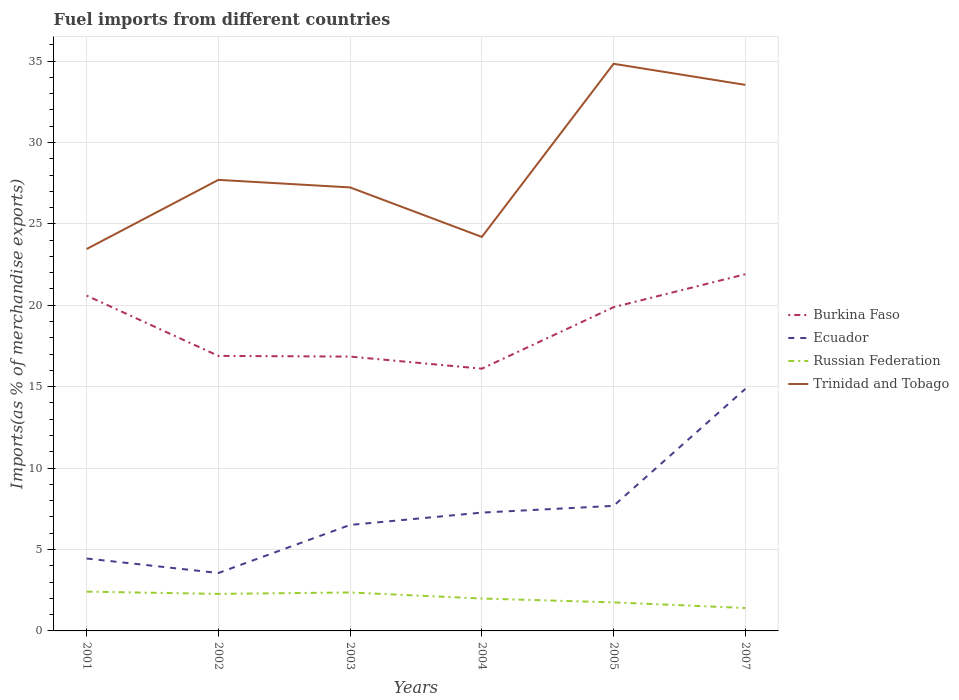How many different coloured lines are there?
Make the answer very short. 4. Does the line corresponding to Ecuador intersect with the line corresponding to Trinidad and Tobago?
Provide a succinct answer. No. Across all years, what is the maximum percentage of imports to different countries in Burkina Faso?
Your answer should be very brief. 16.11. In which year was the percentage of imports to different countries in Russian Federation maximum?
Offer a very short reply. 2007. What is the total percentage of imports to different countries in Ecuador in the graph?
Keep it short and to the point. -8.36. What is the difference between the highest and the second highest percentage of imports to different countries in Russian Federation?
Make the answer very short. 1. What is the difference between the highest and the lowest percentage of imports to different countries in Ecuador?
Offer a very short reply. 2. How many years are there in the graph?
Provide a succinct answer. 6. What is the difference between two consecutive major ticks on the Y-axis?
Provide a short and direct response. 5. Does the graph contain any zero values?
Ensure brevity in your answer.  No. Does the graph contain grids?
Ensure brevity in your answer.  Yes. How many legend labels are there?
Offer a very short reply. 4. What is the title of the graph?
Offer a terse response. Fuel imports from different countries. Does "Middle income" appear as one of the legend labels in the graph?
Keep it short and to the point. No. What is the label or title of the Y-axis?
Provide a succinct answer. Imports(as % of merchandise exports). What is the Imports(as % of merchandise exports) of Burkina Faso in 2001?
Make the answer very short. 20.59. What is the Imports(as % of merchandise exports) in Ecuador in 2001?
Keep it short and to the point. 4.45. What is the Imports(as % of merchandise exports) of Russian Federation in 2001?
Keep it short and to the point. 2.41. What is the Imports(as % of merchandise exports) in Trinidad and Tobago in 2001?
Offer a terse response. 23.46. What is the Imports(as % of merchandise exports) in Burkina Faso in 2002?
Provide a succinct answer. 16.89. What is the Imports(as % of merchandise exports) of Ecuador in 2002?
Give a very brief answer. 3.56. What is the Imports(as % of merchandise exports) in Russian Federation in 2002?
Give a very brief answer. 2.27. What is the Imports(as % of merchandise exports) in Trinidad and Tobago in 2002?
Provide a succinct answer. 27.7. What is the Imports(as % of merchandise exports) in Burkina Faso in 2003?
Keep it short and to the point. 16.85. What is the Imports(as % of merchandise exports) of Ecuador in 2003?
Your answer should be very brief. 6.51. What is the Imports(as % of merchandise exports) of Russian Federation in 2003?
Your answer should be very brief. 2.36. What is the Imports(as % of merchandise exports) of Trinidad and Tobago in 2003?
Your answer should be very brief. 27.24. What is the Imports(as % of merchandise exports) in Burkina Faso in 2004?
Make the answer very short. 16.11. What is the Imports(as % of merchandise exports) in Ecuador in 2004?
Provide a succinct answer. 7.27. What is the Imports(as % of merchandise exports) of Russian Federation in 2004?
Your response must be concise. 1.99. What is the Imports(as % of merchandise exports) of Trinidad and Tobago in 2004?
Your response must be concise. 24.2. What is the Imports(as % of merchandise exports) in Burkina Faso in 2005?
Give a very brief answer. 19.88. What is the Imports(as % of merchandise exports) of Ecuador in 2005?
Your response must be concise. 7.68. What is the Imports(as % of merchandise exports) in Russian Federation in 2005?
Offer a very short reply. 1.75. What is the Imports(as % of merchandise exports) of Trinidad and Tobago in 2005?
Your response must be concise. 34.83. What is the Imports(as % of merchandise exports) of Burkina Faso in 2007?
Offer a terse response. 21.91. What is the Imports(as % of merchandise exports) of Ecuador in 2007?
Offer a very short reply. 14.87. What is the Imports(as % of merchandise exports) of Russian Federation in 2007?
Ensure brevity in your answer.  1.41. What is the Imports(as % of merchandise exports) of Trinidad and Tobago in 2007?
Keep it short and to the point. 33.54. Across all years, what is the maximum Imports(as % of merchandise exports) of Burkina Faso?
Ensure brevity in your answer.  21.91. Across all years, what is the maximum Imports(as % of merchandise exports) of Ecuador?
Keep it short and to the point. 14.87. Across all years, what is the maximum Imports(as % of merchandise exports) of Russian Federation?
Provide a succinct answer. 2.41. Across all years, what is the maximum Imports(as % of merchandise exports) in Trinidad and Tobago?
Offer a terse response. 34.83. Across all years, what is the minimum Imports(as % of merchandise exports) in Burkina Faso?
Make the answer very short. 16.11. Across all years, what is the minimum Imports(as % of merchandise exports) of Ecuador?
Your answer should be compact. 3.56. Across all years, what is the minimum Imports(as % of merchandise exports) in Russian Federation?
Provide a short and direct response. 1.41. Across all years, what is the minimum Imports(as % of merchandise exports) in Trinidad and Tobago?
Provide a short and direct response. 23.46. What is the total Imports(as % of merchandise exports) of Burkina Faso in the graph?
Provide a short and direct response. 112.23. What is the total Imports(as % of merchandise exports) of Ecuador in the graph?
Ensure brevity in your answer.  44.33. What is the total Imports(as % of merchandise exports) in Russian Federation in the graph?
Keep it short and to the point. 12.2. What is the total Imports(as % of merchandise exports) of Trinidad and Tobago in the graph?
Provide a succinct answer. 170.96. What is the difference between the Imports(as % of merchandise exports) in Burkina Faso in 2001 and that in 2002?
Provide a short and direct response. 3.7. What is the difference between the Imports(as % of merchandise exports) of Ecuador in 2001 and that in 2002?
Offer a very short reply. 0.89. What is the difference between the Imports(as % of merchandise exports) of Russian Federation in 2001 and that in 2002?
Your answer should be very brief. 0.14. What is the difference between the Imports(as % of merchandise exports) of Trinidad and Tobago in 2001 and that in 2002?
Give a very brief answer. -4.25. What is the difference between the Imports(as % of merchandise exports) of Burkina Faso in 2001 and that in 2003?
Keep it short and to the point. 3.74. What is the difference between the Imports(as % of merchandise exports) in Ecuador in 2001 and that in 2003?
Your response must be concise. -2.06. What is the difference between the Imports(as % of merchandise exports) of Russian Federation in 2001 and that in 2003?
Your response must be concise. 0.05. What is the difference between the Imports(as % of merchandise exports) of Trinidad and Tobago in 2001 and that in 2003?
Your response must be concise. -3.78. What is the difference between the Imports(as % of merchandise exports) of Burkina Faso in 2001 and that in 2004?
Keep it short and to the point. 4.49. What is the difference between the Imports(as % of merchandise exports) in Ecuador in 2001 and that in 2004?
Offer a very short reply. -2.82. What is the difference between the Imports(as % of merchandise exports) of Russian Federation in 2001 and that in 2004?
Offer a terse response. 0.42. What is the difference between the Imports(as % of merchandise exports) in Trinidad and Tobago in 2001 and that in 2004?
Make the answer very short. -0.74. What is the difference between the Imports(as % of merchandise exports) in Burkina Faso in 2001 and that in 2005?
Provide a succinct answer. 0.71. What is the difference between the Imports(as % of merchandise exports) of Ecuador in 2001 and that in 2005?
Provide a succinct answer. -3.23. What is the difference between the Imports(as % of merchandise exports) of Russian Federation in 2001 and that in 2005?
Ensure brevity in your answer.  0.66. What is the difference between the Imports(as % of merchandise exports) in Trinidad and Tobago in 2001 and that in 2005?
Your answer should be compact. -11.38. What is the difference between the Imports(as % of merchandise exports) in Burkina Faso in 2001 and that in 2007?
Keep it short and to the point. -1.31. What is the difference between the Imports(as % of merchandise exports) in Ecuador in 2001 and that in 2007?
Ensure brevity in your answer.  -10.42. What is the difference between the Imports(as % of merchandise exports) in Trinidad and Tobago in 2001 and that in 2007?
Offer a very short reply. -10.08. What is the difference between the Imports(as % of merchandise exports) of Burkina Faso in 2002 and that in 2003?
Keep it short and to the point. 0.04. What is the difference between the Imports(as % of merchandise exports) in Ecuador in 2002 and that in 2003?
Keep it short and to the point. -2.95. What is the difference between the Imports(as % of merchandise exports) in Russian Federation in 2002 and that in 2003?
Provide a short and direct response. -0.09. What is the difference between the Imports(as % of merchandise exports) of Trinidad and Tobago in 2002 and that in 2003?
Your response must be concise. 0.46. What is the difference between the Imports(as % of merchandise exports) of Burkina Faso in 2002 and that in 2004?
Give a very brief answer. 0.78. What is the difference between the Imports(as % of merchandise exports) in Ecuador in 2002 and that in 2004?
Keep it short and to the point. -3.71. What is the difference between the Imports(as % of merchandise exports) in Russian Federation in 2002 and that in 2004?
Ensure brevity in your answer.  0.28. What is the difference between the Imports(as % of merchandise exports) in Trinidad and Tobago in 2002 and that in 2004?
Offer a terse response. 3.5. What is the difference between the Imports(as % of merchandise exports) of Burkina Faso in 2002 and that in 2005?
Offer a very short reply. -2.99. What is the difference between the Imports(as % of merchandise exports) in Ecuador in 2002 and that in 2005?
Ensure brevity in your answer.  -4.12. What is the difference between the Imports(as % of merchandise exports) of Russian Federation in 2002 and that in 2005?
Give a very brief answer. 0.52. What is the difference between the Imports(as % of merchandise exports) of Trinidad and Tobago in 2002 and that in 2005?
Your answer should be very brief. -7.13. What is the difference between the Imports(as % of merchandise exports) of Burkina Faso in 2002 and that in 2007?
Offer a very short reply. -5.02. What is the difference between the Imports(as % of merchandise exports) of Ecuador in 2002 and that in 2007?
Give a very brief answer. -11.31. What is the difference between the Imports(as % of merchandise exports) in Russian Federation in 2002 and that in 2007?
Offer a very short reply. 0.87. What is the difference between the Imports(as % of merchandise exports) in Trinidad and Tobago in 2002 and that in 2007?
Provide a succinct answer. -5.83. What is the difference between the Imports(as % of merchandise exports) of Burkina Faso in 2003 and that in 2004?
Provide a succinct answer. 0.74. What is the difference between the Imports(as % of merchandise exports) in Ecuador in 2003 and that in 2004?
Make the answer very short. -0.76. What is the difference between the Imports(as % of merchandise exports) in Russian Federation in 2003 and that in 2004?
Ensure brevity in your answer.  0.37. What is the difference between the Imports(as % of merchandise exports) in Trinidad and Tobago in 2003 and that in 2004?
Make the answer very short. 3.04. What is the difference between the Imports(as % of merchandise exports) in Burkina Faso in 2003 and that in 2005?
Your response must be concise. -3.04. What is the difference between the Imports(as % of merchandise exports) in Ecuador in 2003 and that in 2005?
Offer a terse response. -1.17. What is the difference between the Imports(as % of merchandise exports) of Russian Federation in 2003 and that in 2005?
Offer a terse response. 0.61. What is the difference between the Imports(as % of merchandise exports) in Trinidad and Tobago in 2003 and that in 2005?
Give a very brief answer. -7.59. What is the difference between the Imports(as % of merchandise exports) of Burkina Faso in 2003 and that in 2007?
Give a very brief answer. -5.06. What is the difference between the Imports(as % of merchandise exports) in Ecuador in 2003 and that in 2007?
Make the answer very short. -8.36. What is the difference between the Imports(as % of merchandise exports) in Russian Federation in 2003 and that in 2007?
Your answer should be very brief. 0.95. What is the difference between the Imports(as % of merchandise exports) in Trinidad and Tobago in 2003 and that in 2007?
Offer a very short reply. -6.3. What is the difference between the Imports(as % of merchandise exports) in Burkina Faso in 2004 and that in 2005?
Your answer should be very brief. -3.78. What is the difference between the Imports(as % of merchandise exports) of Ecuador in 2004 and that in 2005?
Provide a succinct answer. -0.41. What is the difference between the Imports(as % of merchandise exports) of Russian Federation in 2004 and that in 2005?
Make the answer very short. 0.24. What is the difference between the Imports(as % of merchandise exports) in Trinidad and Tobago in 2004 and that in 2005?
Ensure brevity in your answer.  -10.63. What is the difference between the Imports(as % of merchandise exports) of Burkina Faso in 2004 and that in 2007?
Offer a very short reply. -5.8. What is the difference between the Imports(as % of merchandise exports) of Ecuador in 2004 and that in 2007?
Offer a terse response. -7.6. What is the difference between the Imports(as % of merchandise exports) of Russian Federation in 2004 and that in 2007?
Ensure brevity in your answer.  0.58. What is the difference between the Imports(as % of merchandise exports) of Trinidad and Tobago in 2004 and that in 2007?
Your answer should be compact. -9.34. What is the difference between the Imports(as % of merchandise exports) in Burkina Faso in 2005 and that in 2007?
Your answer should be compact. -2.02. What is the difference between the Imports(as % of merchandise exports) of Ecuador in 2005 and that in 2007?
Provide a short and direct response. -7.19. What is the difference between the Imports(as % of merchandise exports) of Russian Federation in 2005 and that in 2007?
Offer a terse response. 0.35. What is the difference between the Imports(as % of merchandise exports) in Trinidad and Tobago in 2005 and that in 2007?
Keep it short and to the point. 1.3. What is the difference between the Imports(as % of merchandise exports) in Burkina Faso in 2001 and the Imports(as % of merchandise exports) in Ecuador in 2002?
Your response must be concise. 17.04. What is the difference between the Imports(as % of merchandise exports) in Burkina Faso in 2001 and the Imports(as % of merchandise exports) in Russian Federation in 2002?
Make the answer very short. 18.32. What is the difference between the Imports(as % of merchandise exports) in Burkina Faso in 2001 and the Imports(as % of merchandise exports) in Trinidad and Tobago in 2002?
Your answer should be compact. -7.11. What is the difference between the Imports(as % of merchandise exports) of Ecuador in 2001 and the Imports(as % of merchandise exports) of Russian Federation in 2002?
Your answer should be compact. 2.17. What is the difference between the Imports(as % of merchandise exports) of Ecuador in 2001 and the Imports(as % of merchandise exports) of Trinidad and Tobago in 2002?
Ensure brevity in your answer.  -23.26. What is the difference between the Imports(as % of merchandise exports) of Russian Federation in 2001 and the Imports(as % of merchandise exports) of Trinidad and Tobago in 2002?
Make the answer very short. -25.29. What is the difference between the Imports(as % of merchandise exports) in Burkina Faso in 2001 and the Imports(as % of merchandise exports) in Ecuador in 2003?
Give a very brief answer. 14.08. What is the difference between the Imports(as % of merchandise exports) of Burkina Faso in 2001 and the Imports(as % of merchandise exports) of Russian Federation in 2003?
Offer a very short reply. 18.23. What is the difference between the Imports(as % of merchandise exports) of Burkina Faso in 2001 and the Imports(as % of merchandise exports) of Trinidad and Tobago in 2003?
Keep it short and to the point. -6.64. What is the difference between the Imports(as % of merchandise exports) in Ecuador in 2001 and the Imports(as % of merchandise exports) in Russian Federation in 2003?
Keep it short and to the point. 2.08. What is the difference between the Imports(as % of merchandise exports) in Ecuador in 2001 and the Imports(as % of merchandise exports) in Trinidad and Tobago in 2003?
Provide a succinct answer. -22.79. What is the difference between the Imports(as % of merchandise exports) of Russian Federation in 2001 and the Imports(as % of merchandise exports) of Trinidad and Tobago in 2003?
Make the answer very short. -24.83. What is the difference between the Imports(as % of merchandise exports) in Burkina Faso in 2001 and the Imports(as % of merchandise exports) in Ecuador in 2004?
Your response must be concise. 13.33. What is the difference between the Imports(as % of merchandise exports) in Burkina Faso in 2001 and the Imports(as % of merchandise exports) in Russian Federation in 2004?
Keep it short and to the point. 18.6. What is the difference between the Imports(as % of merchandise exports) of Burkina Faso in 2001 and the Imports(as % of merchandise exports) of Trinidad and Tobago in 2004?
Provide a short and direct response. -3.6. What is the difference between the Imports(as % of merchandise exports) of Ecuador in 2001 and the Imports(as % of merchandise exports) of Russian Federation in 2004?
Your response must be concise. 2.46. What is the difference between the Imports(as % of merchandise exports) of Ecuador in 2001 and the Imports(as % of merchandise exports) of Trinidad and Tobago in 2004?
Offer a very short reply. -19.75. What is the difference between the Imports(as % of merchandise exports) of Russian Federation in 2001 and the Imports(as % of merchandise exports) of Trinidad and Tobago in 2004?
Your answer should be compact. -21.79. What is the difference between the Imports(as % of merchandise exports) of Burkina Faso in 2001 and the Imports(as % of merchandise exports) of Ecuador in 2005?
Give a very brief answer. 12.91. What is the difference between the Imports(as % of merchandise exports) in Burkina Faso in 2001 and the Imports(as % of merchandise exports) in Russian Federation in 2005?
Offer a terse response. 18.84. What is the difference between the Imports(as % of merchandise exports) of Burkina Faso in 2001 and the Imports(as % of merchandise exports) of Trinidad and Tobago in 2005?
Offer a very short reply. -14.24. What is the difference between the Imports(as % of merchandise exports) in Ecuador in 2001 and the Imports(as % of merchandise exports) in Russian Federation in 2005?
Offer a very short reply. 2.69. What is the difference between the Imports(as % of merchandise exports) in Ecuador in 2001 and the Imports(as % of merchandise exports) in Trinidad and Tobago in 2005?
Make the answer very short. -30.38. What is the difference between the Imports(as % of merchandise exports) of Russian Federation in 2001 and the Imports(as % of merchandise exports) of Trinidad and Tobago in 2005?
Your answer should be compact. -32.42. What is the difference between the Imports(as % of merchandise exports) in Burkina Faso in 2001 and the Imports(as % of merchandise exports) in Ecuador in 2007?
Your answer should be compact. 5.73. What is the difference between the Imports(as % of merchandise exports) of Burkina Faso in 2001 and the Imports(as % of merchandise exports) of Russian Federation in 2007?
Offer a terse response. 19.19. What is the difference between the Imports(as % of merchandise exports) of Burkina Faso in 2001 and the Imports(as % of merchandise exports) of Trinidad and Tobago in 2007?
Provide a succinct answer. -12.94. What is the difference between the Imports(as % of merchandise exports) of Ecuador in 2001 and the Imports(as % of merchandise exports) of Russian Federation in 2007?
Offer a terse response. 3.04. What is the difference between the Imports(as % of merchandise exports) of Ecuador in 2001 and the Imports(as % of merchandise exports) of Trinidad and Tobago in 2007?
Your response must be concise. -29.09. What is the difference between the Imports(as % of merchandise exports) in Russian Federation in 2001 and the Imports(as % of merchandise exports) in Trinidad and Tobago in 2007?
Keep it short and to the point. -31.12. What is the difference between the Imports(as % of merchandise exports) in Burkina Faso in 2002 and the Imports(as % of merchandise exports) in Ecuador in 2003?
Keep it short and to the point. 10.38. What is the difference between the Imports(as % of merchandise exports) of Burkina Faso in 2002 and the Imports(as % of merchandise exports) of Russian Federation in 2003?
Provide a succinct answer. 14.53. What is the difference between the Imports(as % of merchandise exports) in Burkina Faso in 2002 and the Imports(as % of merchandise exports) in Trinidad and Tobago in 2003?
Ensure brevity in your answer.  -10.35. What is the difference between the Imports(as % of merchandise exports) of Ecuador in 2002 and the Imports(as % of merchandise exports) of Russian Federation in 2003?
Offer a very short reply. 1.2. What is the difference between the Imports(as % of merchandise exports) in Ecuador in 2002 and the Imports(as % of merchandise exports) in Trinidad and Tobago in 2003?
Ensure brevity in your answer.  -23.68. What is the difference between the Imports(as % of merchandise exports) of Russian Federation in 2002 and the Imports(as % of merchandise exports) of Trinidad and Tobago in 2003?
Offer a terse response. -24.96. What is the difference between the Imports(as % of merchandise exports) of Burkina Faso in 2002 and the Imports(as % of merchandise exports) of Ecuador in 2004?
Your answer should be compact. 9.62. What is the difference between the Imports(as % of merchandise exports) in Burkina Faso in 2002 and the Imports(as % of merchandise exports) in Russian Federation in 2004?
Ensure brevity in your answer.  14.9. What is the difference between the Imports(as % of merchandise exports) in Burkina Faso in 2002 and the Imports(as % of merchandise exports) in Trinidad and Tobago in 2004?
Make the answer very short. -7.31. What is the difference between the Imports(as % of merchandise exports) in Ecuador in 2002 and the Imports(as % of merchandise exports) in Russian Federation in 2004?
Make the answer very short. 1.57. What is the difference between the Imports(as % of merchandise exports) in Ecuador in 2002 and the Imports(as % of merchandise exports) in Trinidad and Tobago in 2004?
Your response must be concise. -20.64. What is the difference between the Imports(as % of merchandise exports) in Russian Federation in 2002 and the Imports(as % of merchandise exports) in Trinidad and Tobago in 2004?
Ensure brevity in your answer.  -21.92. What is the difference between the Imports(as % of merchandise exports) of Burkina Faso in 2002 and the Imports(as % of merchandise exports) of Ecuador in 2005?
Give a very brief answer. 9.21. What is the difference between the Imports(as % of merchandise exports) in Burkina Faso in 2002 and the Imports(as % of merchandise exports) in Russian Federation in 2005?
Ensure brevity in your answer.  15.14. What is the difference between the Imports(as % of merchandise exports) in Burkina Faso in 2002 and the Imports(as % of merchandise exports) in Trinidad and Tobago in 2005?
Make the answer very short. -17.94. What is the difference between the Imports(as % of merchandise exports) in Ecuador in 2002 and the Imports(as % of merchandise exports) in Russian Federation in 2005?
Keep it short and to the point. 1.8. What is the difference between the Imports(as % of merchandise exports) of Ecuador in 2002 and the Imports(as % of merchandise exports) of Trinidad and Tobago in 2005?
Give a very brief answer. -31.27. What is the difference between the Imports(as % of merchandise exports) in Russian Federation in 2002 and the Imports(as % of merchandise exports) in Trinidad and Tobago in 2005?
Make the answer very short. -32.56. What is the difference between the Imports(as % of merchandise exports) of Burkina Faso in 2002 and the Imports(as % of merchandise exports) of Ecuador in 2007?
Offer a terse response. 2.02. What is the difference between the Imports(as % of merchandise exports) of Burkina Faso in 2002 and the Imports(as % of merchandise exports) of Russian Federation in 2007?
Provide a short and direct response. 15.48. What is the difference between the Imports(as % of merchandise exports) of Burkina Faso in 2002 and the Imports(as % of merchandise exports) of Trinidad and Tobago in 2007?
Offer a terse response. -16.65. What is the difference between the Imports(as % of merchandise exports) in Ecuador in 2002 and the Imports(as % of merchandise exports) in Russian Federation in 2007?
Give a very brief answer. 2.15. What is the difference between the Imports(as % of merchandise exports) of Ecuador in 2002 and the Imports(as % of merchandise exports) of Trinidad and Tobago in 2007?
Offer a terse response. -29.98. What is the difference between the Imports(as % of merchandise exports) of Russian Federation in 2002 and the Imports(as % of merchandise exports) of Trinidad and Tobago in 2007?
Keep it short and to the point. -31.26. What is the difference between the Imports(as % of merchandise exports) of Burkina Faso in 2003 and the Imports(as % of merchandise exports) of Ecuador in 2004?
Your answer should be compact. 9.58. What is the difference between the Imports(as % of merchandise exports) of Burkina Faso in 2003 and the Imports(as % of merchandise exports) of Russian Federation in 2004?
Your answer should be compact. 14.86. What is the difference between the Imports(as % of merchandise exports) of Burkina Faso in 2003 and the Imports(as % of merchandise exports) of Trinidad and Tobago in 2004?
Ensure brevity in your answer.  -7.35. What is the difference between the Imports(as % of merchandise exports) of Ecuador in 2003 and the Imports(as % of merchandise exports) of Russian Federation in 2004?
Offer a terse response. 4.52. What is the difference between the Imports(as % of merchandise exports) in Ecuador in 2003 and the Imports(as % of merchandise exports) in Trinidad and Tobago in 2004?
Provide a succinct answer. -17.69. What is the difference between the Imports(as % of merchandise exports) in Russian Federation in 2003 and the Imports(as % of merchandise exports) in Trinidad and Tobago in 2004?
Provide a short and direct response. -21.84. What is the difference between the Imports(as % of merchandise exports) in Burkina Faso in 2003 and the Imports(as % of merchandise exports) in Ecuador in 2005?
Provide a succinct answer. 9.17. What is the difference between the Imports(as % of merchandise exports) of Burkina Faso in 2003 and the Imports(as % of merchandise exports) of Russian Federation in 2005?
Keep it short and to the point. 15.1. What is the difference between the Imports(as % of merchandise exports) of Burkina Faso in 2003 and the Imports(as % of merchandise exports) of Trinidad and Tobago in 2005?
Provide a succinct answer. -17.98. What is the difference between the Imports(as % of merchandise exports) in Ecuador in 2003 and the Imports(as % of merchandise exports) in Russian Federation in 2005?
Provide a succinct answer. 4.76. What is the difference between the Imports(as % of merchandise exports) of Ecuador in 2003 and the Imports(as % of merchandise exports) of Trinidad and Tobago in 2005?
Offer a terse response. -28.32. What is the difference between the Imports(as % of merchandise exports) in Russian Federation in 2003 and the Imports(as % of merchandise exports) in Trinidad and Tobago in 2005?
Keep it short and to the point. -32.47. What is the difference between the Imports(as % of merchandise exports) in Burkina Faso in 2003 and the Imports(as % of merchandise exports) in Ecuador in 2007?
Provide a succinct answer. 1.98. What is the difference between the Imports(as % of merchandise exports) in Burkina Faso in 2003 and the Imports(as % of merchandise exports) in Russian Federation in 2007?
Keep it short and to the point. 15.44. What is the difference between the Imports(as % of merchandise exports) of Burkina Faso in 2003 and the Imports(as % of merchandise exports) of Trinidad and Tobago in 2007?
Keep it short and to the point. -16.69. What is the difference between the Imports(as % of merchandise exports) in Ecuador in 2003 and the Imports(as % of merchandise exports) in Russian Federation in 2007?
Your response must be concise. 5.1. What is the difference between the Imports(as % of merchandise exports) in Ecuador in 2003 and the Imports(as % of merchandise exports) in Trinidad and Tobago in 2007?
Give a very brief answer. -27.03. What is the difference between the Imports(as % of merchandise exports) of Russian Federation in 2003 and the Imports(as % of merchandise exports) of Trinidad and Tobago in 2007?
Ensure brevity in your answer.  -31.17. What is the difference between the Imports(as % of merchandise exports) of Burkina Faso in 2004 and the Imports(as % of merchandise exports) of Ecuador in 2005?
Keep it short and to the point. 8.42. What is the difference between the Imports(as % of merchandise exports) of Burkina Faso in 2004 and the Imports(as % of merchandise exports) of Russian Federation in 2005?
Ensure brevity in your answer.  14.35. What is the difference between the Imports(as % of merchandise exports) of Burkina Faso in 2004 and the Imports(as % of merchandise exports) of Trinidad and Tobago in 2005?
Keep it short and to the point. -18.73. What is the difference between the Imports(as % of merchandise exports) of Ecuador in 2004 and the Imports(as % of merchandise exports) of Russian Federation in 2005?
Offer a very short reply. 5.51. What is the difference between the Imports(as % of merchandise exports) in Ecuador in 2004 and the Imports(as % of merchandise exports) in Trinidad and Tobago in 2005?
Keep it short and to the point. -27.56. What is the difference between the Imports(as % of merchandise exports) in Russian Federation in 2004 and the Imports(as % of merchandise exports) in Trinidad and Tobago in 2005?
Provide a succinct answer. -32.84. What is the difference between the Imports(as % of merchandise exports) in Burkina Faso in 2004 and the Imports(as % of merchandise exports) in Ecuador in 2007?
Make the answer very short. 1.24. What is the difference between the Imports(as % of merchandise exports) in Burkina Faso in 2004 and the Imports(as % of merchandise exports) in Russian Federation in 2007?
Make the answer very short. 14.7. What is the difference between the Imports(as % of merchandise exports) in Burkina Faso in 2004 and the Imports(as % of merchandise exports) in Trinidad and Tobago in 2007?
Make the answer very short. -17.43. What is the difference between the Imports(as % of merchandise exports) in Ecuador in 2004 and the Imports(as % of merchandise exports) in Russian Federation in 2007?
Give a very brief answer. 5.86. What is the difference between the Imports(as % of merchandise exports) in Ecuador in 2004 and the Imports(as % of merchandise exports) in Trinidad and Tobago in 2007?
Ensure brevity in your answer.  -26.27. What is the difference between the Imports(as % of merchandise exports) of Russian Federation in 2004 and the Imports(as % of merchandise exports) of Trinidad and Tobago in 2007?
Provide a short and direct response. -31.55. What is the difference between the Imports(as % of merchandise exports) in Burkina Faso in 2005 and the Imports(as % of merchandise exports) in Ecuador in 2007?
Give a very brief answer. 5.02. What is the difference between the Imports(as % of merchandise exports) of Burkina Faso in 2005 and the Imports(as % of merchandise exports) of Russian Federation in 2007?
Provide a succinct answer. 18.48. What is the difference between the Imports(as % of merchandise exports) of Burkina Faso in 2005 and the Imports(as % of merchandise exports) of Trinidad and Tobago in 2007?
Provide a succinct answer. -13.65. What is the difference between the Imports(as % of merchandise exports) of Ecuador in 2005 and the Imports(as % of merchandise exports) of Russian Federation in 2007?
Make the answer very short. 6.27. What is the difference between the Imports(as % of merchandise exports) in Ecuador in 2005 and the Imports(as % of merchandise exports) in Trinidad and Tobago in 2007?
Offer a terse response. -25.85. What is the difference between the Imports(as % of merchandise exports) of Russian Federation in 2005 and the Imports(as % of merchandise exports) of Trinidad and Tobago in 2007?
Your answer should be very brief. -31.78. What is the average Imports(as % of merchandise exports) in Burkina Faso per year?
Your answer should be compact. 18.71. What is the average Imports(as % of merchandise exports) of Ecuador per year?
Give a very brief answer. 7.39. What is the average Imports(as % of merchandise exports) in Russian Federation per year?
Your answer should be compact. 2.03. What is the average Imports(as % of merchandise exports) in Trinidad and Tobago per year?
Your response must be concise. 28.49. In the year 2001, what is the difference between the Imports(as % of merchandise exports) of Burkina Faso and Imports(as % of merchandise exports) of Ecuador?
Give a very brief answer. 16.15. In the year 2001, what is the difference between the Imports(as % of merchandise exports) of Burkina Faso and Imports(as % of merchandise exports) of Russian Federation?
Provide a succinct answer. 18.18. In the year 2001, what is the difference between the Imports(as % of merchandise exports) in Burkina Faso and Imports(as % of merchandise exports) in Trinidad and Tobago?
Your response must be concise. -2.86. In the year 2001, what is the difference between the Imports(as % of merchandise exports) in Ecuador and Imports(as % of merchandise exports) in Russian Federation?
Provide a succinct answer. 2.03. In the year 2001, what is the difference between the Imports(as % of merchandise exports) of Ecuador and Imports(as % of merchandise exports) of Trinidad and Tobago?
Make the answer very short. -19.01. In the year 2001, what is the difference between the Imports(as % of merchandise exports) of Russian Federation and Imports(as % of merchandise exports) of Trinidad and Tobago?
Provide a short and direct response. -21.04. In the year 2002, what is the difference between the Imports(as % of merchandise exports) of Burkina Faso and Imports(as % of merchandise exports) of Ecuador?
Your answer should be very brief. 13.33. In the year 2002, what is the difference between the Imports(as % of merchandise exports) in Burkina Faso and Imports(as % of merchandise exports) in Russian Federation?
Your answer should be compact. 14.62. In the year 2002, what is the difference between the Imports(as % of merchandise exports) in Burkina Faso and Imports(as % of merchandise exports) in Trinidad and Tobago?
Make the answer very short. -10.81. In the year 2002, what is the difference between the Imports(as % of merchandise exports) in Ecuador and Imports(as % of merchandise exports) in Russian Federation?
Offer a very short reply. 1.28. In the year 2002, what is the difference between the Imports(as % of merchandise exports) in Ecuador and Imports(as % of merchandise exports) in Trinidad and Tobago?
Make the answer very short. -24.14. In the year 2002, what is the difference between the Imports(as % of merchandise exports) in Russian Federation and Imports(as % of merchandise exports) in Trinidad and Tobago?
Your answer should be very brief. -25.43. In the year 2003, what is the difference between the Imports(as % of merchandise exports) of Burkina Faso and Imports(as % of merchandise exports) of Ecuador?
Give a very brief answer. 10.34. In the year 2003, what is the difference between the Imports(as % of merchandise exports) of Burkina Faso and Imports(as % of merchandise exports) of Russian Federation?
Offer a terse response. 14.49. In the year 2003, what is the difference between the Imports(as % of merchandise exports) of Burkina Faso and Imports(as % of merchandise exports) of Trinidad and Tobago?
Give a very brief answer. -10.39. In the year 2003, what is the difference between the Imports(as % of merchandise exports) in Ecuador and Imports(as % of merchandise exports) in Russian Federation?
Keep it short and to the point. 4.15. In the year 2003, what is the difference between the Imports(as % of merchandise exports) in Ecuador and Imports(as % of merchandise exports) in Trinidad and Tobago?
Offer a very short reply. -20.73. In the year 2003, what is the difference between the Imports(as % of merchandise exports) of Russian Federation and Imports(as % of merchandise exports) of Trinidad and Tobago?
Keep it short and to the point. -24.88. In the year 2004, what is the difference between the Imports(as % of merchandise exports) of Burkina Faso and Imports(as % of merchandise exports) of Ecuador?
Give a very brief answer. 8.84. In the year 2004, what is the difference between the Imports(as % of merchandise exports) in Burkina Faso and Imports(as % of merchandise exports) in Russian Federation?
Your answer should be compact. 14.12. In the year 2004, what is the difference between the Imports(as % of merchandise exports) in Burkina Faso and Imports(as % of merchandise exports) in Trinidad and Tobago?
Keep it short and to the point. -8.09. In the year 2004, what is the difference between the Imports(as % of merchandise exports) of Ecuador and Imports(as % of merchandise exports) of Russian Federation?
Your answer should be very brief. 5.28. In the year 2004, what is the difference between the Imports(as % of merchandise exports) in Ecuador and Imports(as % of merchandise exports) in Trinidad and Tobago?
Ensure brevity in your answer.  -16.93. In the year 2004, what is the difference between the Imports(as % of merchandise exports) of Russian Federation and Imports(as % of merchandise exports) of Trinidad and Tobago?
Offer a very short reply. -22.21. In the year 2005, what is the difference between the Imports(as % of merchandise exports) in Burkina Faso and Imports(as % of merchandise exports) in Ecuador?
Provide a short and direct response. 12.2. In the year 2005, what is the difference between the Imports(as % of merchandise exports) in Burkina Faso and Imports(as % of merchandise exports) in Russian Federation?
Your answer should be very brief. 18.13. In the year 2005, what is the difference between the Imports(as % of merchandise exports) in Burkina Faso and Imports(as % of merchandise exports) in Trinidad and Tobago?
Offer a terse response. -14.95. In the year 2005, what is the difference between the Imports(as % of merchandise exports) of Ecuador and Imports(as % of merchandise exports) of Russian Federation?
Keep it short and to the point. 5.93. In the year 2005, what is the difference between the Imports(as % of merchandise exports) of Ecuador and Imports(as % of merchandise exports) of Trinidad and Tobago?
Keep it short and to the point. -27.15. In the year 2005, what is the difference between the Imports(as % of merchandise exports) in Russian Federation and Imports(as % of merchandise exports) in Trinidad and Tobago?
Provide a short and direct response. -33.08. In the year 2007, what is the difference between the Imports(as % of merchandise exports) of Burkina Faso and Imports(as % of merchandise exports) of Ecuador?
Make the answer very short. 7.04. In the year 2007, what is the difference between the Imports(as % of merchandise exports) of Burkina Faso and Imports(as % of merchandise exports) of Russian Federation?
Keep it short and to the point. 20.5. In the year 2007, what is the difference between the Imports(as % of merchandise exports) in Burkina Faso and Imports(as % of merchandise exports) in Trinidad and Tobago?
Your answer should be compact. -11.63. In the year 2007, what is the difference between the Imports(as % of merchandise exports) in Ecuador and Imports(as % of merchandise exports) in Russian Federation?
Offer a very short reply. 13.46. In the year 2007, what is the difference between the Imports(as % of merchandise exports) in Ecuador and Imports(as % of merchandise exports) in Trinidad and Tobago?
Make the answer very short. -18.67. In the year 2007, what is the difference between the Imports(as % of merchandise exports) in Russian Federation and Imports(as % of merchandise exports) in Trinidad and Tobago?
Your answer should be compact. -32.13. What is the ratio of the Imports(as % of merchandise exports) of Burkina Faso in 2001 to that in 2002?
Your answer should be compact. 1.22. What is the ratio of the Imports(as % of merchandise exports) of Ecuador in 2001 to that in 2002?
Give a very brief answer. 1.25. What is the ratio of the Imports(as % of merchandise exports) in Russian Federation in 2001 to that in 2002?
Make the answer very short. 1.06. What is the ratio of the Imports(as % of merchandise exports) of Trinidad and Tobago in 2001 to that in 2002?
Give a very brief answer. 0.85. What is the ratio of the Imports(as % of merchandise exports) in Burkina Faso in 2001 to that in 2003?
Provide a short and direct response. 1.22. What is the ratio of the Imports(as % of merchandise exports) in Ecuador in 2001 to that in 2003?
Your response must be concise. 0.68. What is the ratio of the Imports(as % of merchandise exports) of Russian Federation in 2001 to that in 2003?
Your response must be concise. 1.02. What is the ratio of the Imports(as % of merchandise exports) in Trinidad and Tobago in 2001 to that in 2003?
Give a very brief answer. 0.86. What is the ratio of the Imports(as % of merchandise exports) of Burkina Faso in 2001 to that in 2004?
Your answer should be very brief. 1.28. What is the ratio of the Imports(as % of merchandise exports) of Ecuador in 2001 to that in 2004?
Offer a terse response. 0.61. What is the ratio of the Imports(as % of merchandise exports) in Russian Federation in 2001 to that in 2004?
Offer a terse response. 1.21. What is the ratio of the Imports(as % of merchandise exports) of Trinidad and Tobago in 2001 to that in 2004?
Offer a terse response. 0.97. What is the ratio of the Imports(as % of merchandise exports) in Burkina Faso in 2001 to that in 2005?
Offer a very short reply. 1.04. What is the ratio of the Imports(as % of merchandise exports) in Ecuador in 2001 to that in 2005?
Your answer should be compact. 0.58. What is the ratio of the Imports(as % of merchandise exports) of Russian Federation in 2001 to that in 2005?
Provide a succinct answer. 1.38. What is the ratio of the Imports(as % of merchandise exports) in Trinidad and Tobago in 2001 to that in 2005?
Make the answer very short. 0.67. What is the ratio of the Imports(as % of merchandise exports) in Ecuador in 2001 to that in 2007?
Make the answer very short. 0.3. What is the ratio of the Imports(as % of merchandise exports) in Russian Federation in 2001 to that in 2007?
Your answer should be compact. 1.71. What is the ratio of the Imports(as % of merchandise exports) in Trinidad and Tobago in 2001 to that in 2007?
Provide a succinct answer. 0.7. What is the ratio of the Imports(as % of merchandise exports) in Burkina Faso in 2002 to that in 2003?
Ensure brevity in your answer.  1. What is the ratio of the Imports(as % of merchandise exports) in Ecuador in 2002 to that in 2003?
Ensure brevity in your answer.  0.55. What is the ratio of the Imports(as % of merchandise exports) in Russian Federation in 2002 to that in 2003?
Give a very brief answer. 0.96. What is the ratio of the Imports(as % of merchandise exports) of Burkina Faso in 2002 to that in 2004?
Provide a short and direct response. 1.05. What is the ratio of the Imports(as % of merchandise exports) in Ecuador in 2002 to that in 2004?
Provide a short and direct response. 0.49. What is the ratio of the Imports(as % of merchandise exports) of Russian Federation in 2002 to that in 2004?
Your answer should be very brief. 1.14. What is the ratio of the Imports(as % of merchandise exports) in Trinidad and Tobago in 2002 to that in 2004?
Provide a short and direct response. 1.14. What is the ratio of the Imports(as % of merchandise exports) of Burkina Faso in 2002 to that in 2005?
Keep it short and to the point. 0.85. What is the ratio of the Imports(as % of merchandise exports) in Ecuador in 2002 to that in 2005?
Your answer should be compact. 0.46. What is the ratio of the Imports(as % of merchandise exports) in Russian Federation in 2002 to that in 2005?
Your answer should be compact. 1.3. What is the ratio of the Imports(as % of merchandise exports) of Trinidad and Tobago in 2002 to that in 2005?
Your response must be concise. 0.8. What is the ratio of the Imports(as % of merchandise exports) of Burkina Faso in 2002 to that in 2007?
Offer a terse response. 0.77. What is the ratio of the Imports(as % of merchandise exports) in Ecuador in 2002 to that in 2007?
Your answer should be very brief. 0.24. What is the ratio of the Imports(as % of merchandise exports) of Russian Federation in 2002 to that in 2007?
Offer a very short reply. 1.62. What is the ratio of the Imports(as % of merchandise exports) in Trinidad and Tobago in 2002 to that in 2007?
Provide a succinct answer. 0.83. What is the ratio of the Imports(as % of merchandise exports) in Burkina Faso in 2003 to that in 2004?
Your answer should be very brief. 1.05. What is the ratio of the Imports(as % of merchandise exports) of Ecuador in 2003 to that in 2004?
Make the answer very short. 0.9. What is the ratio of the Imports(as % of merchandise exports) of Russian Federation in 2003 to that in 2004?
Ensure brevity in your answer.  1.19. What is the ratio of the Imports(as % of merchandise exports) of Trinidad and Tobago in 2003 to that in 2004?
Keep it short and to the point. 1.13. What is the ratio of the Imports(as % of merchandise exports) in Burkina Faso in 2003 to that in 2005?
Offer a terse response. 0.85. What is the ratio of the Imports(as % of merchandise exports) of Ecuador in 2003 to that in 2005?
Ensure brevity in your answer.  0.85. What is the ratio of the Imports(as % of merchandise exports) of Russian Federation in 2003 to that in 2005?
Ensure brevity in your answer.  1.35. What is the ratio of the Imports(as % of merchandise exports) of Trinidad and Tobago in 2003 to that in 2005?
Offer a terse response. 0.78. What is the ratio of the Imports(as % of merchandise exports) of Burkina Faso in 2003 to that in 2007?
Provide a short and direct response. 0.77. What is the ratio of the Imports(as % of merchandise exports) of Ecuador in 2003 to that in 2007?
Provide a short and direct response. 0.44. What is the ratio of the Imports(as % of merchandise exports) of Russian Federation in 2003 to that in 2007?
Offer a very short reply. 1.68. What is the ratio of the Imports(as % of merchandise exports) of Trinidad and Tobago in 2003 to that in 2007?
Ensure brevity in your answer.  0.81. What is the ratio of the Imports(as % of merchandise exports) of Burkina Faso in 2004 to that in 2005?
Your answer should be very brief. 0.81. What is the ratio of the Imports(as % of merchandise exports) in Ecuador in 2004 to that in 2005?
Ensure brevity in your answer.  0.95. What is the ratio of the Imports(as % of merchandise exports) of Russian Federation in 2004 to that in 2005?
Provide a succinct answer. 1.13. What is the ratio of the Imports(as % of merchandise exports) of Trinidad and Tobago in 2004 to that in 2005?
Offer a very short reply. 0.69. What is the ratio of the Imports(as % of merchandise exports) of Burkina Faso in 2004 to that in 2007?
Provide a short and direct response. 0.74. What is the ratio of the Imports(as % of merchandise exports) of Ecuador in 2004 to that in 2007?
Keep it short and to the point. 0.49. What is the ratio of the Imports(as % of merchandise exports) in Russian Federation in 2004 to that in 2007?
Offer a very short reply. 1.41. What is the ratio of the Imports(as % of merchandise exports) in Trinidad and Tobago in 2004 to that in 2007?
Your response must be concise. 0.72. What is the ratio of the Imports(as % of merchandise exports) in Burkina Faso in 2005 to that in 2007?
Keep it short and to the point. 0.91. What is the ratio of the Imports(as % of merchandise exports) in Ecuador in 2005 to that in 2007?
Make the answer very short. 0.52. What is the ratio of the Imports(as % of merchandise exports) in Russian Federation in 2005 to that in 2007?
Offer a terse response. 1.25. What is the ratio of the Imports(as % of merchandise exports) of Trinidad and Tobago in 2005 to that in 2007?
Your response must be concise. 1.04. What is the difference between the highest and the second highest Imports(as % of merchandise exports) in Burkina Faso?
Your response must be concise. 1.31. What is the difference between the highest and the second highest Imports(as % of merchandise exports) of Ecuador?
Make the answer very short. 7.19. What is the difference between the highest and the second highest Imports(as % of merchandise exports) in Russian Federation?
Give a very brief answer. 0.05. What is the difference between the highest and the second highest Imports(as % of merchandise exports) in Trinidad and Tobago?
Offer a terse response. 1.3. What is the difference between the highest and the lowest Imports(as % of merchandise exports) of Burkina Faso?
Make the answer very short. 5.8. What is the difference between the highest and the lowest Imports(as % of merchandise exports) in Ecuador?
Your answer should be very brief. 11.31. What is the difference between the highest and the lowest Imports(as % of merchandise exports) in Trinidad and Tobago?
Your answer should be very brief. 11.38. 